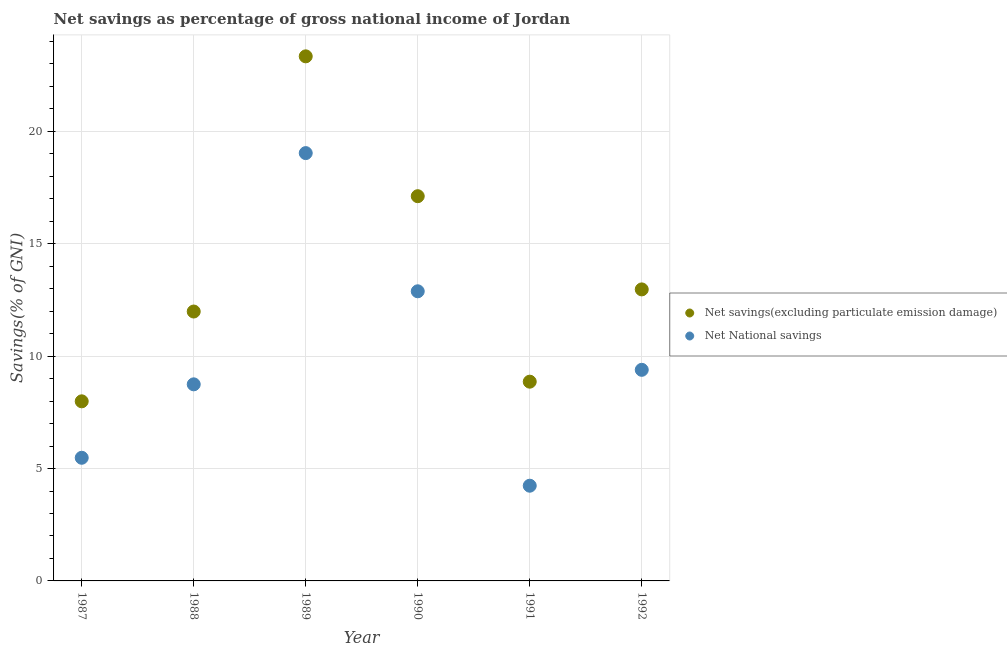How many different coloured dotlines are there?
Offer a terse response. 2. Is the number of dotlines equal to the number of legend labels?
Offer a terse response. Yes. What is the net savings(excluding particulate emission damage) in 1990?
Your answer should be compact. 17.12. Across all years, what is the maximum net national savings?
Provide a short and direct response. 19.03. Across all years, what is the minimum net national savings?
Your response must be concise. 4.24. In which year was the net national savings minimum?
Your answer should be compact. 1991. What is the total net national savings in the graph?
Give a very brief answer. 59.77. What is the difference between the net savings(excluding particulate emission damage) in 1987 and that in 1989?
Provide a succinct answer. -15.35. What is the difference between the net savings(excluding particulate emission damage) in 1989 and the net national savings in 1988?
Your answer should be compact. 14.59. What is the average net savings(excluding particulate emission damage) per year?
Provide a succinct answer. 13.71. In the year 1988, what is the difference between the net savings(excluding particulate emission damage) and net national savings?
Keep it short and to the point. 3.24. In how many years, is the net national savings greater than 3 %?
Make the answer very short. 6. What is the ratio of the net national savings in 1987 to that in 1992?
Keep it short and to the point. 0.58. Is the net savings(excluding particulate emission damage) in 1988 less than that in 1992?
Keep it short and to the point. Yes. Is the difference between the net savings(excluding particulate emission damage) in 1988 and 1989 greater than the difference between the net national savings in 1988 and 1989?
Keep it short and to the point. No. What is the difference between the highest and the second highest net national savings?
Offer a very short reply. 6.15. What is the difference between the highest and the lowest net national savings?
Offer a very short reply. 14.8. Does the net national savings monotonically increase over the years?
Ensure brevity in your answer.  No. Is the net national savings strictly greater than the net savings(excluding particulate emission damage) over the years?
Ensure brevity in your answer.  No. Is the net national savings strictly less than the net savings(excluding particulate emission damage) over the years?
Give a very brief answer. Yes. How many dotlines are there?
Provide a short and direct response. 2. How many years are there in the graph?
Your response must be concise. 6. What is the difference between two consecutive major ticks on the Y-axis?
Provide a short and direct response. 5. Are the values on the major ticks of Y-axis written in scientific E-notation?
Make the answer very short. No. Where does the legend appear in the graph?
Offer a terse response. Center right. What is the title of the graph?
Give a very brief answer. Net savings as percentage of gross national income of Jordan. What is the label or title of the Y-axis?
Your response must be concise. Savings(% of GNI). What is the Savings(% of GNI) in Net savings(excluding particulate emission damage) in 1987?
Offer a terse response. 7.99. What is the Savings(% of GNI) of Net National savings in 1987?
Offer a terse response. 5.48. What is the Savings(% of GNI) of Net savings(excluding particulate emission damage) in 1988?
Your answer should be very brief. 11.99. What is the Savings(% of GNI) in Net National savings in 1988?
Your answer should be compact. 8.75. What is the Savings(% of GNI) of Net savings(excluding particulate emission damage) in 1989?
Make the answer very short. 23.34. What is the Savings(% of GNI) of Net National savings in 1989?
Provide a short and direct response. 19.03. What is the Savings(% of GNI) in Net savings(excluding particulate emission damage) in 1990?
Your answer should be compact. 17.12. What is the Savings(% of GNI) of Net National savings in 1990?
Your response must be concise. 12.89. What is the Savings(% of GNI) in Net savings(excluding particulate emission damage) in 1991?
Provide a succinct answer. 8.86. What is the Savings(% of GNI) in Net National savings in 1991?
Make the answer very short. 4.24. What is the Savings(% of GNI) of Net savings(excluding particulate emission damage) in 1992?
Ensure brevity in your answer.  12.97. What is the Savings(% of GNI) of Net National savings in 1992?
Keep it short and to the point. 9.39. Across all years, what is the maximum Savings(% of GNI) of Net savings(excluding particulate emission damage)?
Ensure brevity in your answer.  23.34. Across all years, what is the maximum Savings(% of GNI) of Net National savings?
Ensure brevity in your answer.  19.03. Across all years, what is the minimum Savings(% of GNI) of Net savings(excluding particulate emission damage)?
Offer a very short reply. 7.99. Across all years, what is the minimum Savings(% of GNI) in Net National savings?
Give a very brief answer. 4.24. What is the total Savings(% of GNI) of Net savings(excluding particulate emission damage) in the graph?
Offer a very short reply. 82.27. What is the total Savings(% of GNI) in Net National savings in the graph?
Your response must be concise. 59.77. What is the difference between the Savings(% of GNI) in Net savings(excluding particulate emission damage) in 1987 and that in 1988?
Your answer should be very brief. -4. What is the difference between the Savings(% of GNI) of Net National savings in 1987 and that in 1988?
Offer a very short reply. -3.27. What is the difference between the Savings(% of GNI) of Net savings(excluding particulate emission damage) in 1987 and that in 1989?
Your response must be concise. -15.35. What is the difference between the Savings(% of GNI) in Net National savings in 1987 and that in 1989?
Give a very brief answer. -13.56. What is the difference between the Savings(% of GNI) in Net savings(excluding particulate emission damage) in 1987 and that in 1990?
Provide a succinct answer. -9.13. What is the difference between the Savings(% of GNI) of Net National savings in 1987 and that in 1990?
Make the answer very short. -7.41. What is the difference between the Savings(% of GNI) of Net savings(excluding particulate emission damage) in 1987 and that in 1991?
Give a very brief answer. -0.87. What is the difference between the Savings(% of GNI) in Net National savings in 1987 and that in 1991?
Give a very brief answer. 1.24. What is the difference between the Savings(% of GNI) of Net savings(excluding particulate emission damage) in 1987 and that in 1992?
Give a very brief answer. -4.98. What is the difference between the Savings(% of GNI) of Net National savings in 1987 and that in 1992?
Make the answer very short. -3.91. What is the difference between the Savings(% of GNI) in Net savings(excluding particulate emission damage) in 1988 and that in 1989?
Give a very brief answer. -11.35. What is the difference between the Savings(% of GNI) of Net National savings in 1988 and that in 1989?
Keep it short and to the point. -10.29. What is the difference between the Savings(% of GNI) in Net savings(excluding particulate emission damage) in 1988 and that in 1990?
Ensure brevity in your answer.  -5.13. What is the difference between the Savings(% of GNI) of Net National savings in 1988 and that in 1990?
Ensure brevity in your answer.  -4.14. What is the difference between the Savings(% of GNI) in Net savings(excluding particulate emission damage) in 1988 and that in 1991?
Your answer should be very brief. 3.12. What is the difference between the Savings(% of GNI) in Net National savings in 1988 and that in 1991?
Offer a terse response. 4.51. What is the difference between the Savings(% of GNI) of Net savings(excluding particulate emission damage) in 1988 and that in 1992?
Make the answer very short. -0.98. What is the difference between the Savings(% of GNI) of Net National savings in 1988 and that in 1992?
Provide a short and direct response. -0.65. What is the difference between the Savings(% of GNI) in Net savings(excluding particulate emission damage) in 1989 and that in 1990?
Give a very brief answer. 6.22. What is the difference between the Savings(% of GNI) in Net National savings in 1989 and that in 1990?
Keep it short and to the point. 6.15. What is the difference between the Savings(% of GNI) in Net savings(excluding particulate emission damage) in 1989 and that in 1991?
Offer a very short reply. 14.47. What is the difference between the Savings(% of GNI) of Net National savings in 1989 and that in 1991?
Provide a succinct answer. 14.8. What is the difference between the Savings(% of GNI) in Net savings(excluding particulate emission damage) in 1989 and that in 1992?
Provide a succinct answer. 10.37. What is the difference between the Savings(% of GNI) of Net National savings in 1989 and that in 1992?
Your answer should be very brief. 9.64. What is the difference between the Savings(% of GNI) in Net savings(excluding particulate emission damage) in 1990 and that in 1991?
Your answer should be compact. 8.25. What is the difference between the Savings(% of GNI) in Net National savings in 1990 and that in 1991?
Offer a terse response. 8.65. What is the difference between the Savings(% of GNI) of Net savings(excluding particulate emission damage) in 1990 and that in 1992?
Your response must be concise. 4.15. What is the difference between the Savings(% of GNI) of Net National savings in 1990 and that in 1992?
Provide a succinct answer. 3.49. What is the difference between the Savings(% of GNI) of Net savings(excluding particulate emission damage) in 1991 and that in 1992?
Provide a succinct answer. -4.11. What is the difference between the Savings(% of GNI) of Net National savings in 1991 and that in 1992?
Make the answer very short. -5.16. What is the difference between the Savings(% of GNI) of Net savings(excluding particulate emission damage) in 1987 and the Savings(% of GNI) of Net National savings in 1988?
Give a very brief answer. -0.76. What is the difference between the Savings(% of GNI) of Net savings(excluding particulate emission damage) in 1987 and the Savings(% of GNI) of Net National savings in 1989?
Make the answer very short. -11.04. What is the difference between the Savings(% of GNI) of Net savings(excluding particulate emission damage) in 1987 and the Savings(% of GNI) of Net National savings in 1990?
Keep it short and to the point. -4.9. What is the difference between the Savings(% of GNI) of Net savings(excluding particulate emission damage) in 1987 and the Savings(% of GNI) of Net National savings in 1991?
Give a very brief answer. 3.75. What is the difference between the Savings(% of GNI) of Net savings(excluding particulate emission damage) in 1987 and the Savings(% of GNI) of Net National savings in 1992?
Give a very brief answer. -1.4. What is the difference between the Savings(% of GNI) of Net savings(excluding particulate emission damage) in 1988 and the Savings(% of GNI) of Net National savings in 1989?
Keep it short and to the point. -7.05. What is the difference between the Savings(% of GNI) in Net savings(excluding particulate emission damage) in 1988 and the Savings(% of GNI) in Net National savings in 1990?
Give a very brief answer. -0.9. What is the difference between the Savings(% of GNI) in Net savings(excluding particulate emission damage) in 1988 and the Savings(% of GNI) in Net National savings in 1991?
Ensure brevity in your answer.  7.75. What is the difference between the Savings(% of GNI) in Net savings(excluding particulate emission damage) in 1988 and the Savings(% of GNI) in Net National savings in 1992?
Your answer should be very brief. 2.59. What is the difference between the Savings(% of GNI) in Net savings(excluding particulate emission damage) in 1989 and the Savings(% of GNI) in Net National savings in 1990?
Your answer should be compact. 10.45. What is the difference between the Savings(% of GNI) of Net savings(excluding particulate emission damage) in 1989 and the Savings(% of GNI) of Net National savings in 1991?
Your answer should be compact. 19.1. What is the difference between the Savings(% of GNI) of Net savings(excluding particulate emission damage) in 1989 and the Savings(% of GNI) of Net National savings in 1992?
Ensure brevity in your answer.  13.95. What is the difference between the Savings(% of GNI) in Net savings(excluding particulate emission damage) in 1990 and the Savings(% of GNI) in Net National savings in 1991?
Your response must be concise. 12.88. What is the difference between the Savings(% of GNI) of Net savings(excluding particulate emission damage) in 1990 and the Savings(% of GNI) of Net National savings in 1992?
Keep it short and to the point. 7.72. What is the difference between the Savings(% of GNI) of Net savings(excluding particulate emission damage) in 1991 and the Savings(% of GNI) of Net National savings in 1992?
Keep it short and to the point. -0.53. What is the average Savings(% of GNI) in Net savings(excluding particulate emission damage) per year?
Provide a succinct answer. 13.71. What is the average Savings(% of GNI) in Net National savings per year?
Ensure brevity in your answer.  9.96. In the year 1987, what is the difference between the Savings(% of GNI) in Net savings(excluding particulate emission damage) and Savings(% of GNI) in Net National savings?
Provide a succinct answer. 2.51. In the year 1988, what is the difference between the Savings(% of GNI) of Net savings(excluding particulate emission damage) and Savings(% of GNI) of Net National savings?
Offer a very short reply. 3.24. In the year 1989, what is the difference between the Savings(% of GNI) in Net savings(excluding particulate emission damage) and Savings(% of GNI) in Net National savings?
Provide a succinct answer. 4.3. In the year 1990, what is the difference between the Savings(% of GNI) of Net savings(excluding particulate emission damage) and Savings(% of GNI) of Net National savings?
Make the answer very short. 4.23. In the year 1991, what is the difference between the Savings(% of GNI) of Net savings(excluding particulate emission damage) and Savings(% of GNI) of Net National savings?
Offer a very short reply. 4.63. In the year 1992, what is the difference between the Savings(% of GNI) in Net savings(excluding particulate emission damage) and Savings(% of GNI) in Net National savings?
Provide a short and direct response. 3.58. What is the ratio of the Savings(% of GNI) in Net savings(excluding particulate emission damage) in 1987 to that in 1988?
Ensure brevity in your answer.  0.67. What is the ratio of the Savings(% of GNI) of Net National savings in 1987 to that in 1988?
Your answer should be compact. 0.63. What is the ratio of the Savings(% of GNI) of Net savings(excluding particulate emission damage) in 1987 to that in 1989?
Give a very brief answer. 0.34. What is the ratio of the Savings(% of GNI) in Net National savings in 1987 to that in 1989?
Your answer should be compact. 0.29. What is the ratio of the Savings(% of GNI) of Net savings(excluding particulate emission damage) in 1987 to that in 1990?
Make the answer very short. 0.47. What is the ratio of the Savings(% of GNI) in Net National savings in 1987 to that in 1990?
Your response must be concise. 0.43. What is the ratio of the Savings(% of GNI) in Net savings(excluding particulate emission damage) in 1987 to that in 1991?
Your answer should be compact. 0.9. What is the ratio of the Savings(% of GNI) in Net National savings in 1987 to that in 1991?
Your answer should be compact. 1.29. What is the ratio of the Savings(% of GNI) in Net savings(excluding particulate emission damage) in 1987 to that in 1992?
Your answer should be very brief. 0.62. What is the ratio of the Savings(% of GNI) in Net National savings in 1987 to that in 1992?
Your answer should be compact. 0.58. What is the ratio of the Savings(% of GNI) in Net savings(excluding particulate emission damage) in 1988 to that in 1989?
Provide a short and direct response. 0.51. What is the ratio of the Savings(% of GNI) of Net National savings in 1988 to that in 1989?
Provide a succinct answer. 0.46. What is the ratio of the Savings(% of GNI) of Net savings(excluding particulate emission damage) in 1988 to that in 1990?
Offer a terse response. 0.7. What is the ratio of the Savings(% of GNI) of Net National savings in 1988 to that in 1990?
Your answer should be very brief. 0.68. What is the ratio of the Savings(% of GNI) of Net savings(excluding particulate emission damage) in 1988 to that in 1991?
Your answer should be compact. 1.35. What is the ratio of the Savings(% of GNI) of Net National savings in 1988 to that in 1991?
Give a very brief answer. 2.06. What is the ratio of the Savings(% of GNI) of Net savings(excluding particulate emission damage) in 1988 to that in 1992?
Your answer should be compact. 0.92. What is the ratio of the Savings(% of GNI) of Net National savings in 1988 to that in 1992?
Provide a short and direct response. 0.93. What is the ratio of the Savings(% of GNI) in Net savings(excluding particulate emission damage) in 1989 to that in 1990?
Give a very brief answer. 1.36. What is the ratio of the Savings(% of GNI) of Net National savings in 1989 to that in 1990?
Provide a short and direct response. 1.48. What is the ratio of the Savings(% of GNI) of Net savings(excluding particulate emission damage) in 1989 to that in 1991?
Your answer should be very brief. 2.63. What is the ratio of the Savings(% of GNI) of Net National savings in 1989 to that in 1991?
Your answer should be compact. 4.49. What is the ratio of the Savings(% of GNI) of Net savings(excluding particulate emission damage) in 1989 to that in 1992?
Keep it short and to the point. 1.8. What is the ratio of the Savings(% of GNI) in Net National savings in 1989 to that in 1992?
Make the answer very short. 2.03. What is the ratio of the Savings(% of GNI) in Net savings(excluding particulate emission damage) in 1990 to that in 1991?
Make the answer very short. 1.93. What is the ratio of the Savings(% of GNI) in Net National savings in 1990 to that in 1991?
Offer a terse response. 3.04. What is the ratio of the Savings(% of GNI) of Net savings(excluding particulate emission damage) in 1990 to that in 1992?
Provide a short and direct response. 1.32. What is the ratio of the Savings(% of GNI) of Net National savings in 1990 to that in 1992?
Give a very brief answer. 1.37. What is the ratio of the Savings(% of GNI) in Net savings(excluding particulate emission damage) in 1991 to that in 1992?
Give a very brief answer. 0.68. What is the ratio of the Savings(% of GNI) of Net National savings in 1991 to that in 1992?
Offer a very short reply. 0.45. What is the difference between the highest and the second highest Savings(% of GNI) of Net savings(excluding particulate emission damage)?
Your answer should be very brief. 6.22. What is the difference between the highest and the second highest Savings(% of GNI) of Net National savings?
Your answer should be very brief. 6.15. What is the difference between the highest and the lowest Savings(% of GNI) in Net savings(excluding particulate emission damage)?
Ensure brevity in your answer.  15.35. What is the difference between the highest and the lowest Savings(% of GNI) of Net National savings?
Keep it short and to the point. 14.8. 